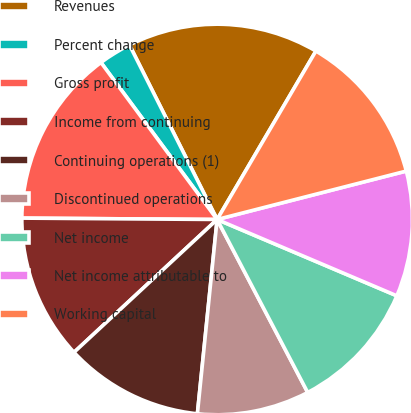Convert chart to OTSL. <chart><loc_0><loc_0><loc_500><loc_500><pie_chart><fcel>Revenues<fcel>Percent change<fcel>Gross profit<fcel>Income from continuing<fcel>Continuing operations (1)<fcel>Discontinued operations<fcel>Net income<fcel>Net income attributable to<fcel>Working capital<nl><fcel>15.85%<fcel>2.73%<fcel>14.75%<fcel>12.02%<fcel>11.48%<fcel>9.29%<fcel>10.93%<fcel>10.38%<fcel>12.57%<nl></chart> 